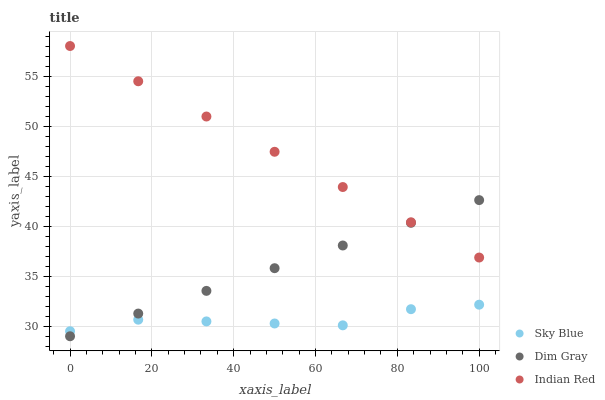Does Sky Blue have the minimum area under the curve?
Answer yes or no. Yes. Does Indian Red have the maximum area under the curve?
Answer yes or no. Yes. Does Dim Gray have the minimum area under the curve?
Answer yes or no. No. Does Dim Gray have the maximum area under the curve?
Answer yes or no. No. Is Dim Gray the smoothest?
Answer yes or no. Yes. Is Sky Blue the roughest?
Answer yes or no. Yes. Is Indian Red the smoothest?
Answer yes or no. No. Is Indian Red the roughest?
Answer yes or no. No. Does Dim Gray have the lowest value?
Answer yes or no. Yes. Does Indian Red have the lowest value?
Answer yes or no. No. Does Indian Red have the highest value?
Answer yes or no. Yes. Does Dim Gray have the highest value?
Answer yes or no. No. Is Sky Blue less than Indian Red?
Answer yes or no. Yes. Is Indian Red greater than Sky Blue?
Answer yes or no. Yes. Does Sky Blue intersect Dim Gray?
Answer yes or no. Yes. Is Sky Blue less than Dim Gray?
Answer yes or no. No. Is Sky Blue greater than Dim Gray?
Answer yes or no. No. Does Sky Blue intersect Indian Red?
Answer yes or no. No. 